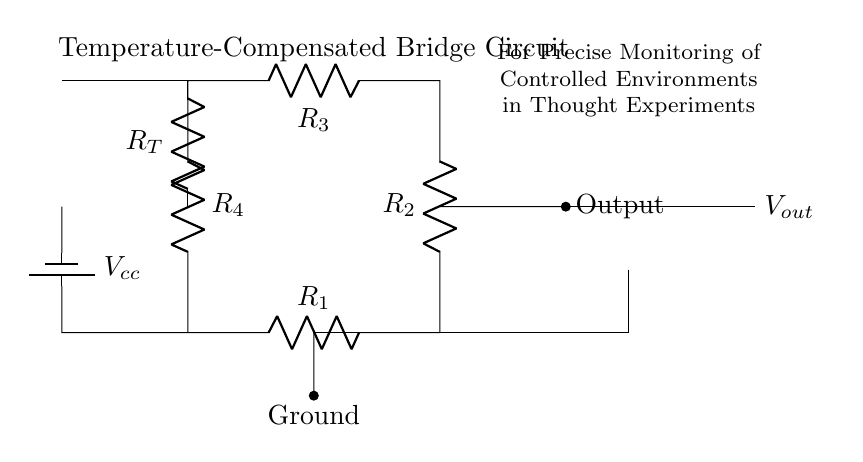What type of circuit is represented? The circuit displayed is a bridge circuit, specifically designed for temperature compensation. The configuration of resistors is indicative of a bridge arrangement for precise measurements.
Answer: bridge circuit What is the purpose of the resistor labeled R_T? The resistor R_T is a temperature-sensitive resistor, which means its resistance changes with temperature, helping to compensate for temperature variations in the measurement circuit, enhancing accuracy.
Answer: temperature-sensitive resistor How many resistors are present in the circuit? The circuit contains four resistors in the bridge formation and one temperature-sensitive resistor, making a total of five resistors.
Answer: five What is the function of the op-amp in this circuit? The operational amplifier (op-amp) amplifies the voltage difference from the bridge circuit, allowing for precise output signals that can be monitored, particularly in controlled environments.
Answer: amplifies voltage difference What is the role of the voltage source in this circuit? The voltage source provides the necessary electrical energy (V_cc) for the circuit to operate, enabling the flow of current through the resistors and ensuring proper functioning of the bridge.
Answer: provides electrical energy What does the output represent in this circuit? The output represents the amplified signal from the temperature-compensated bridge circuit which indicates the change in temperature as detected by R_T; it is essential for monitoring controlled environments.
Answer: amplified signal What is the main benefit of using a temperature-compensated bridge circuit? The main benefit is enhanced accuracy in measuring temperature changes by offsetting the effects of temperature on resistors, providing precise readings in thought experiments where environment control is critical.
Answer: enhanced measurement accuracy 